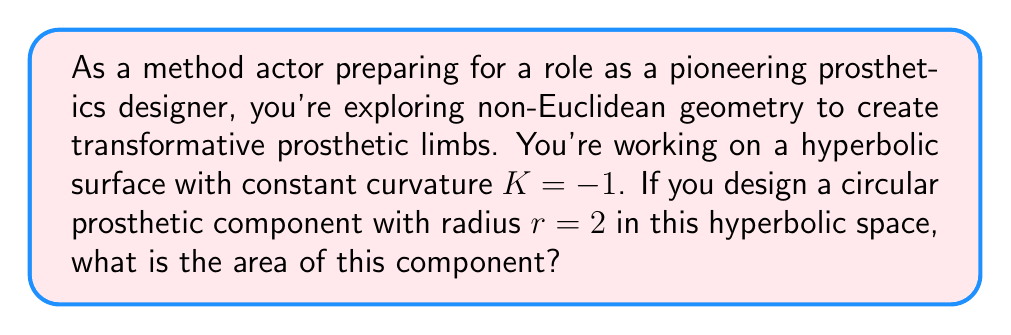Solve this math problem. To solve this problem, we'll follow these steps:

1) In hyperbolic geometry, the formula for the area of a circle is different from Euclidean geometry. The area of a circle in hyperbolic space with constant curvature $K$ is given by:

   $$A = \frac{4\pi}{|K|} \sinh^2\left(\frac{\sqrt{|K|}r}{2}\right)$$

2) We're given that $K = -1$ and $r = 2$. Let's substitute these values:

   $$A = \frac{4\pi}{|-1|} \sinh^2\left(\frac{\sqrt{|-1|}(2)}{2}\right)$$

3) Simplify:
   
   $$A = 4\pi \sinh^2(1)$$

4) Now we need to calculate $\sinh(1)$. The hyperbolic sine function is defined as:

   $$\sinh(x) = \frac{e^x - e^{-x}}{2}$$

5) Calculating $\sinh(1)$:

   $$\sinh(1) = \frac{e^1 - e^{-1}}{2} \approx 1.1752$$

6) Now we can complete our calculation:

   $$A = 4\pi \sinh^2(1) \approx 4\pi(1.1752)^2 \approx 17.2824$$

Therefore, the area of the circular prosthetic component in this hyperbolic space is approximately 17.2824 square units.
Answer: $4\pi \sinh^2(1) \approx 17.2824$ square units 